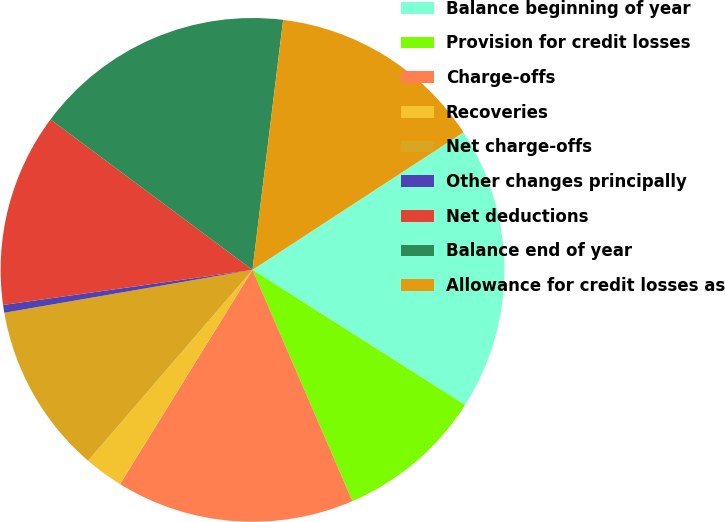Convert chart. <chart><loc_0><loc_0><loc_500><loc_500><pie_chart><fcel>Balance beginning of year<fcel>Provision for credit losses<fcel>Charge-offs<fcel>Recoveries<fcel>Net charge-offs<fcel>Other changes principally<fcel>Net deductions<fcel>Balance end of year<fcel>Allowance for credit losses as<nl><fcel>18.21%<fcel>9.5%<fcel>15.31%<fcel>2.5%<fcel>10.96%<fcel>0.5%<fcel>12.41%<fcel>16.76%<fcel>13.86%<nl></chart> 